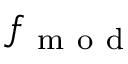<formula> <loc_0><loc_0><loc_500><loc_500>f _ { m o d }</formula> 